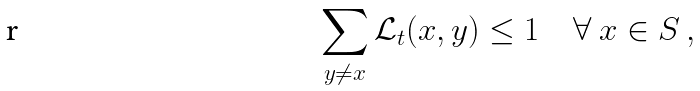Convert formula to latex. <formula><loc_0><loc_0><loc_500><loc_500>\sum _ { y \neq x } { \mathcal { L } } _ { t } ( x , y ) \leq 1 \quad \forall \ x \in S \, ,</formula> 